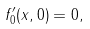Convert formula to latex. <formula><loc_0><loc_0><loc_500><loc_500>f ^ { \prime } _ { 0 } ( x , 0 ) = 0 ,</formula> 